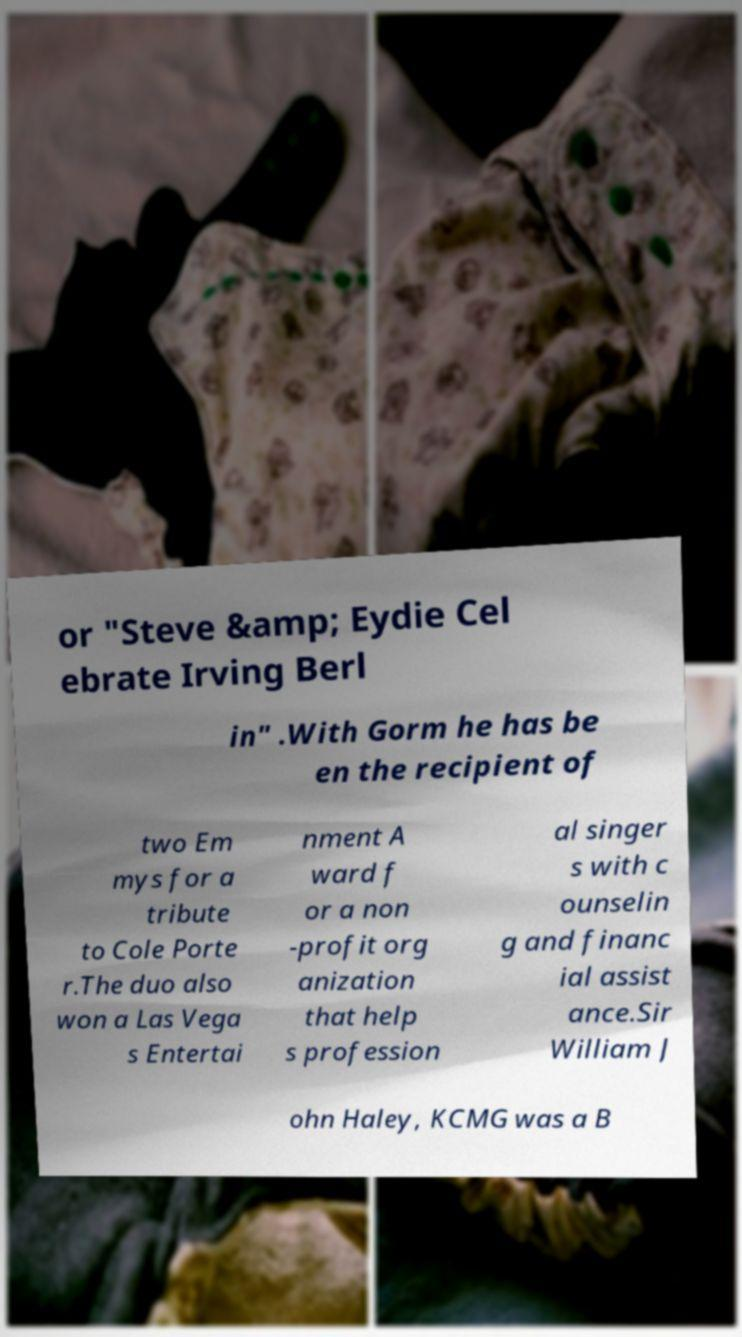Could you assist in decoding the text presented in this image and type it out clearly? or "Steve &amp; Eydie Cel ebrate Irving Berl in" .With Gorm he has be en the recipient of two Em mys for a tribute to Cole Porte r.The duo also won a Las Vega s Entertai nment A ward f or a non -profit org anization that help s profession al singer s with c ounselin g and financ ial assist ance.Sir William J ohn Haley, KCMG was a B 